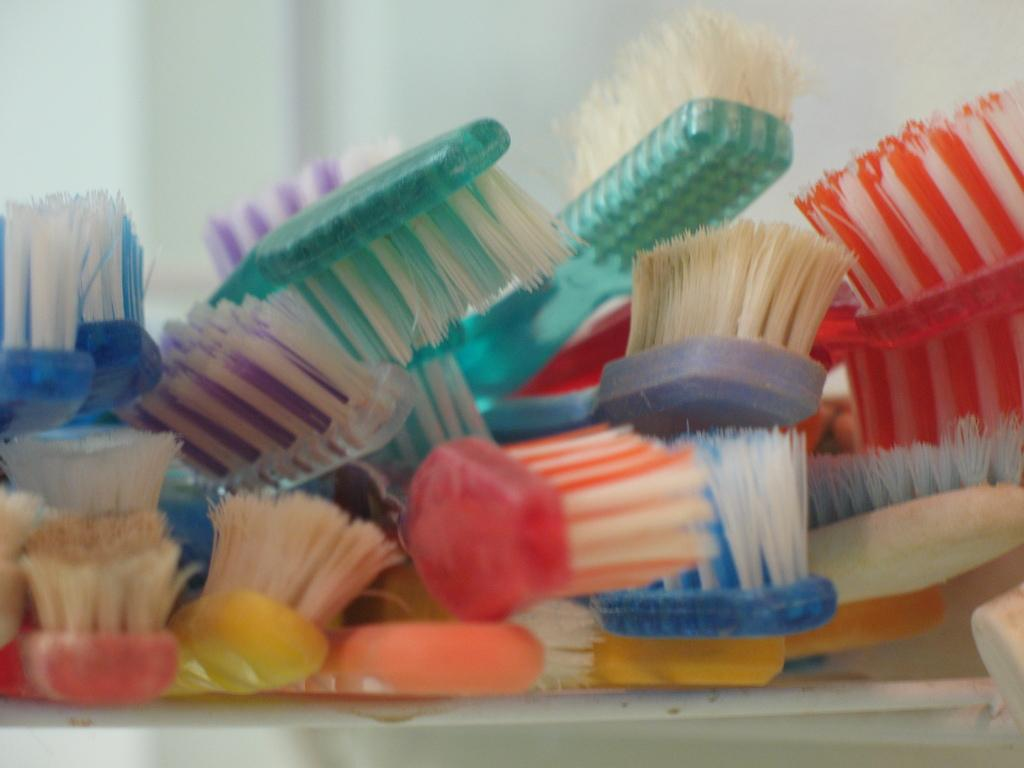What objects are present in the image? There are colorful brushes in the image. What color is the background of the image? The background of the image is white. Can you see any drops of produce on the brushes in the image? There are no drops of produce visible on the brushes in the image. 